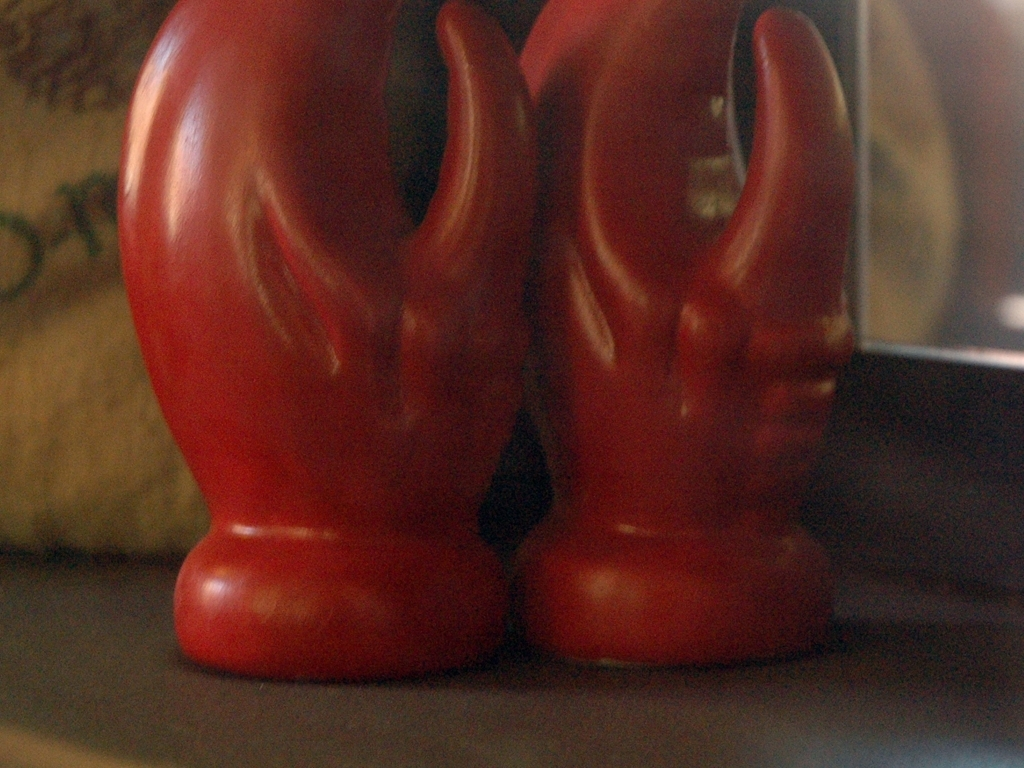Can you tell me what the objects in the photo might be used for? The red objects in the photo appear to be decorative statues, potentially used as bookends or ornamental pieces to enhance the aesthetic of a room. 